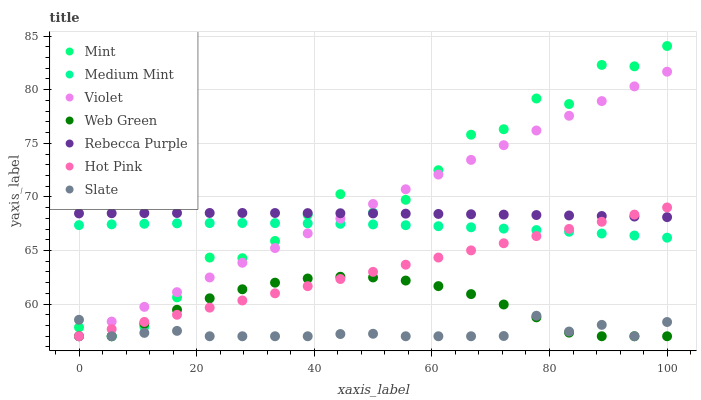Does Slate have the minimum area under the curve?
Answer yes or no. Yes. Does Mint have the maximum area under the curve?
Answer yes or no. Yes. Does Hot Pink have the minimum area under the curve?
Answer yes or no. No. Does Hot Pink have the maximum area under the curve?
Answer yes or no. No. Is Hot Pink the smoothest?
Answer yes or no. Yes. Is Mint the roughest?
Answer yes or no. Yes. Is Slate the smoothest?
Answer yes or no. No. Is Slate the roughest?
Answer yes or no. No. Does Slate have the lowest value?
Answer yes or no. Yes. Does Rebecca Purple have the lowest value?
Answer yes or no. No. Does Mint have the highest value?
Answer yes or no. Yes. Does Hot Pink have the highest value?
Answer yes or no. No. Is Web Green less than Rebecca Purple?
Answer yes or no. Yes. Is Medium Mint greater than Slate?
Answer yes or no. Yes. Does Slate intersect Hot Pink?
Answer yes or no. Yes. Is Slate less than Hot Pink?
Answer yes or no. No. Is Slate greater than Hot Pink?
Answer yes or no. No. Does Web Green intersect Rebecca Purple?
Answer yes or no. No. 